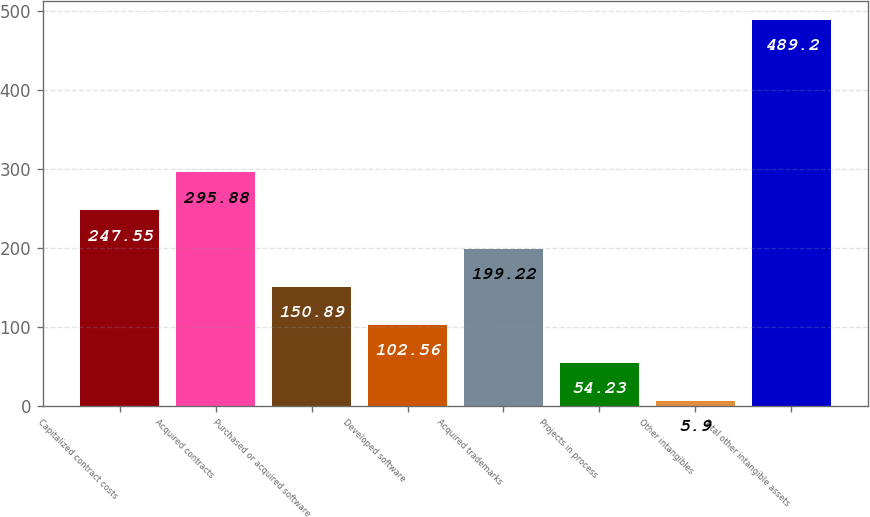Convert chart to OTSL. <chart><loc_0><loc_0><loc_500><loc_500><bar_chart><fcel>Capitalized contract costs<fcel>Acquired contracts<fcel>Purchased or acquired software<fcel>Developed software<fcel>Acquired trademarks<fcel>Projects in process<fcel>Other intangibles<fcel>Total other intangible assets<nl><fcel>247.55<fcel>295.88<fcel>150.89<fcel>102.56<fcel>199.22<fcel>54.23<fcel>5.9<fcel>489.2<nl></chart> 